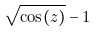<formula> <loc_0><loc_0><loc_500><loc_500>\sqrt { \cos ( z ) } - 1</formula> 